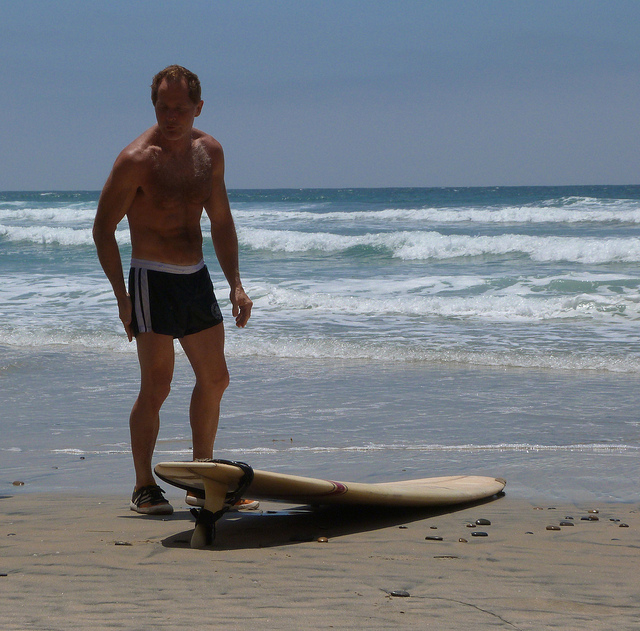Is the man about to surf or has he just finished surfing? Based on the image, it is difficult to definitively determine whether the man is about to surf or has just finished surfing. His stance and the way he is looking at the surfboard suggest he could be preparing for a surf session by checking or adjusting his gear. However, it's equally possible that he has just completed a surfing session and is now unwinding on the shore. 